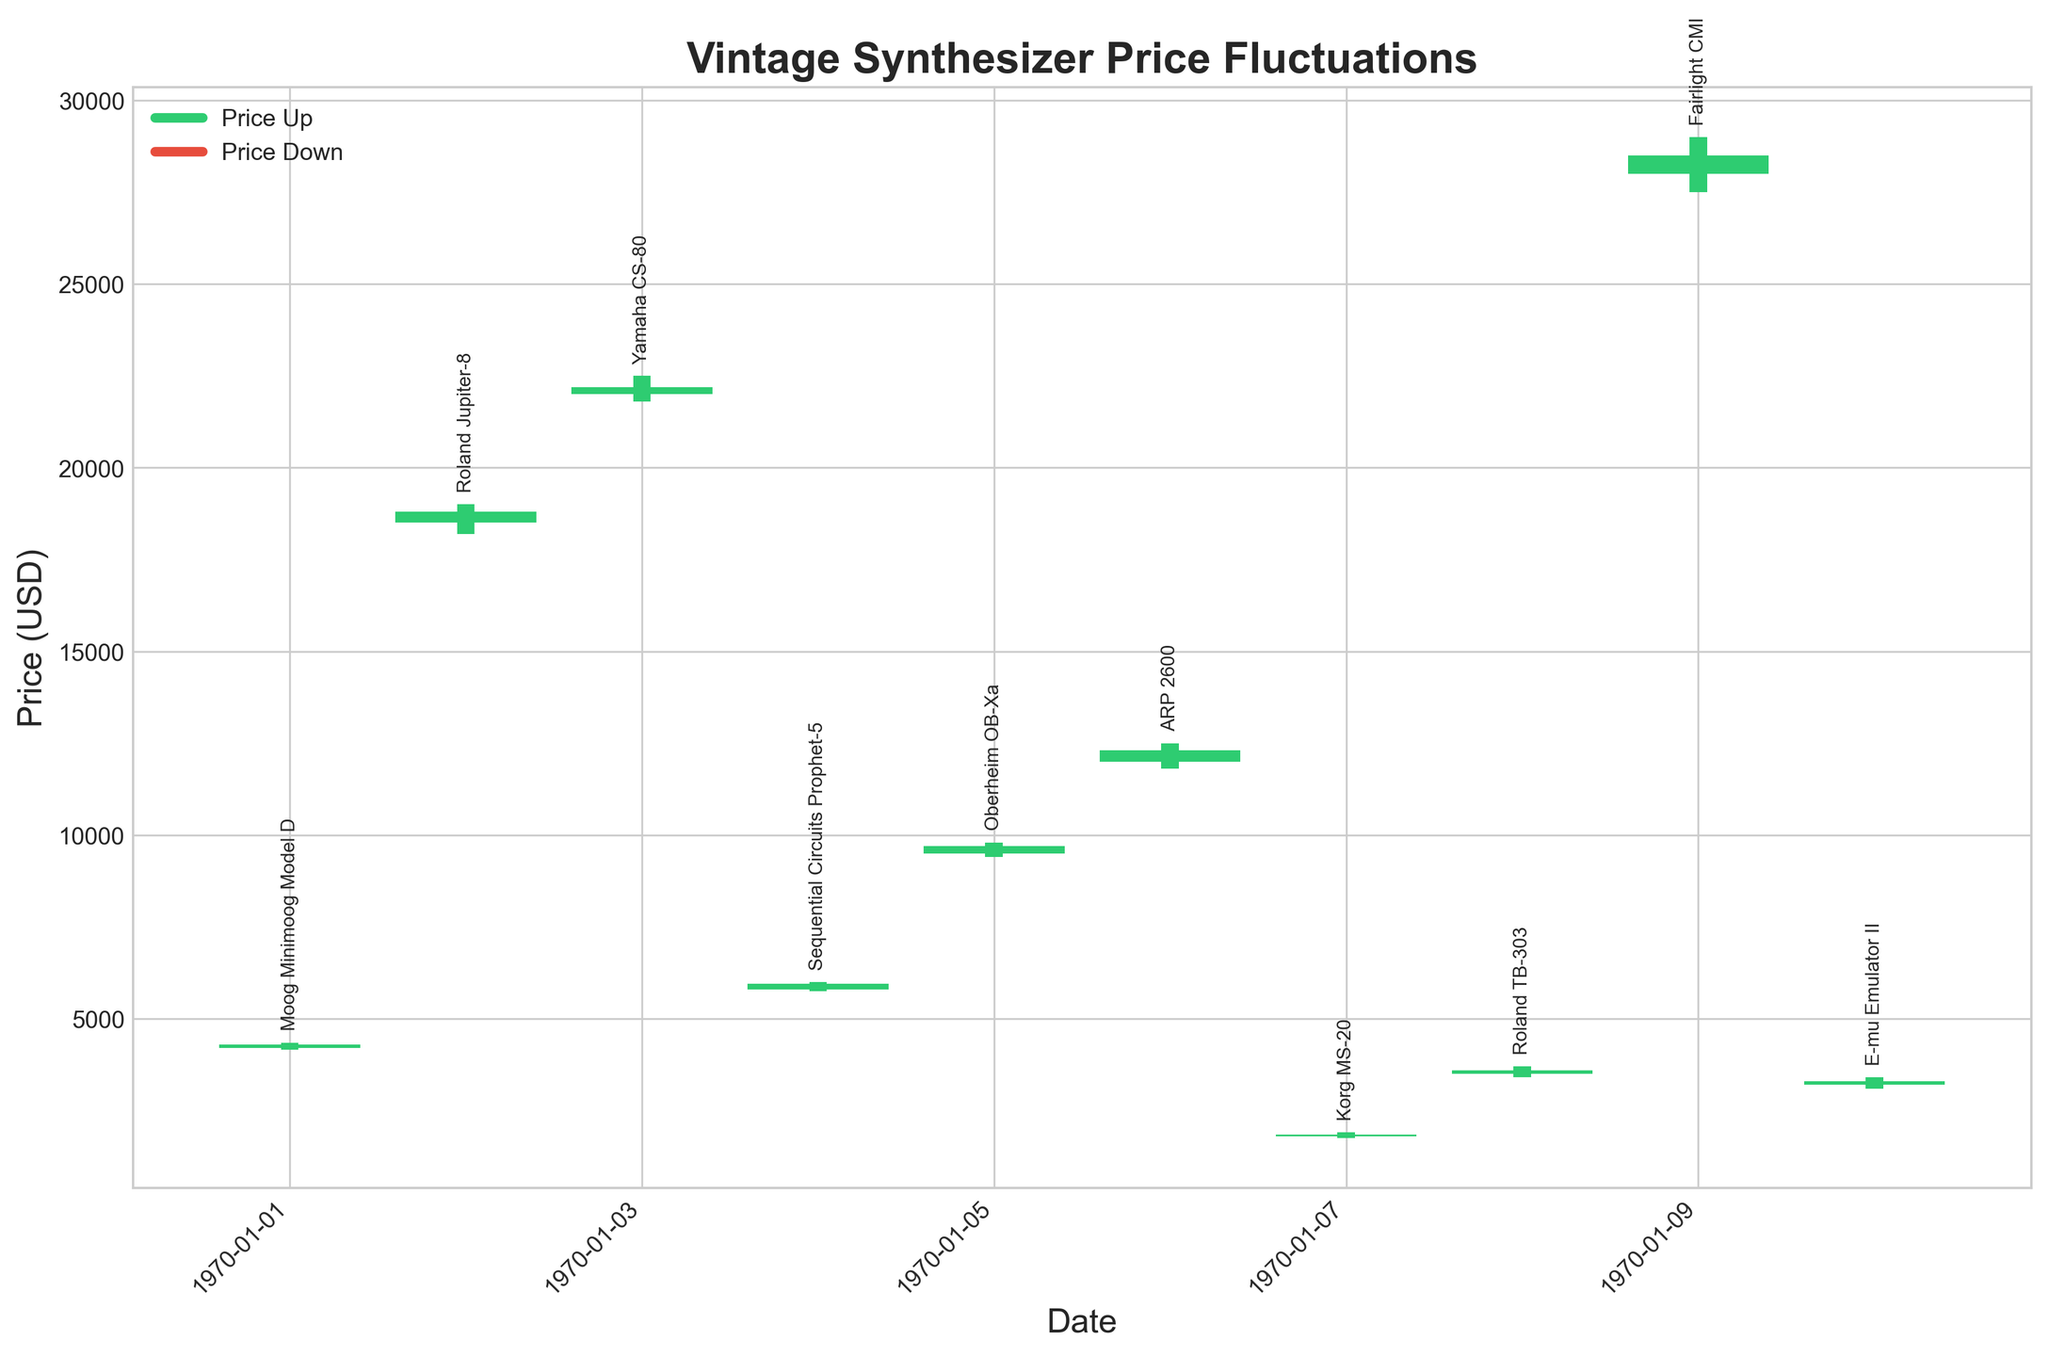Which synthesizer model experienced the highest price increase? The highest price increase is determined by the difference between the close and open prices where the close price is higher. In this case, the ARP 2600 increased from 12000 to 12300, resulting in a 300 USD increase.
Answer: ARP 2600 Which day had the highest closing price? The highest closing price can be identified by looking at the 'Close' column. The highest closing price on the chart is for the Fairlight CMI on May 9, with a closing price of 28500.
Answer: May 9 Which synthesizer model had the lowest low price? To determine which synthesizer had the lowest low price, we can refer to the 'Low' column. The Korg MS-20 had the lowest low price of 1750 USD.
Answer: Korg MS-20 How many synthesizer models had a closing price lower than their opening price? This can be determined by counting the bars that are red (indicating a closing price lower than the opening price). There are 3 models: Roland TB-303, Fairlight CMI, and E-mu Emulator II.
Answer: 3 models Which day saw the highest fluctuation in price for any synthesizer, and what was the model? The highest fluctuation can be determined by the difference between the high and low prices on a given day. The ARP 2600 showed the highest fluctuation with a high of 12500 and a low of 11800, a range of 700 USD.
Answer: May 6, ARP 2600 Which synthesizer model had the highest closing price on the last day in the data? Looking at the 'Close' column for the last date (May 10), the E-mu Emulator II had the highest closing price of 3300 USD.
Answer: E-mu Emulator II What is the average closing price of all synthesizers listed in the data? To get the average closing price, sum the closing prices and divide by the number of models. (4300 + 18800 + 22200 + 5950 + 9700 + 12300 + 1850 + 3600 + 28500 + 3300) / 10 = 12350 USD.
Answer: 12350 USD Which synthesizer model had the smallest difference between its high and low price? By examining the 'High' and 'Low' columns, the Roland Jupiter-8 had the smallest difference between its high and low prices with a difference of 800 USD (19000 - 18200).
Answer: Roland Jupiter-8 